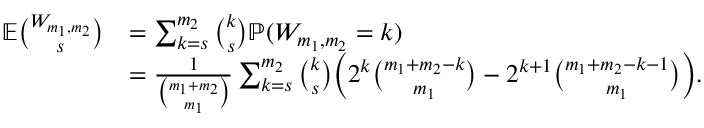Convert formula to latex. <formula><loc_0><loc_0><loc_500><loc_500>\begin{array} { r l } { { \mathbb { E } } \binom { W _ { m _ { 1 } , m _ { 2 } } } { s } } & { = \sum _ { k = s } ^ { m _ { 2 } } \binom { k } s { \mathbb { P } } ( W _ { m _ { 1 } , m _ { 2 } } = k ) } \\ & { = \frac { 1 } { \binom { m _ { 1 } + m _ { 2 } } { m _ { 1 } } } \sum _ { k = s } ^ { m _ { 2 } } \binom { k } s \left ( 2 ^ { k } \binom { m _ { 1 } + m _ { 2 } - k } { m _ { 1 } } - 2 ^ { k + 1 } \binom { m _ { 1 } + m _ { 2 } - k - 1 } { m _ { 1 } } \right ) . } \end{array}</formula> 